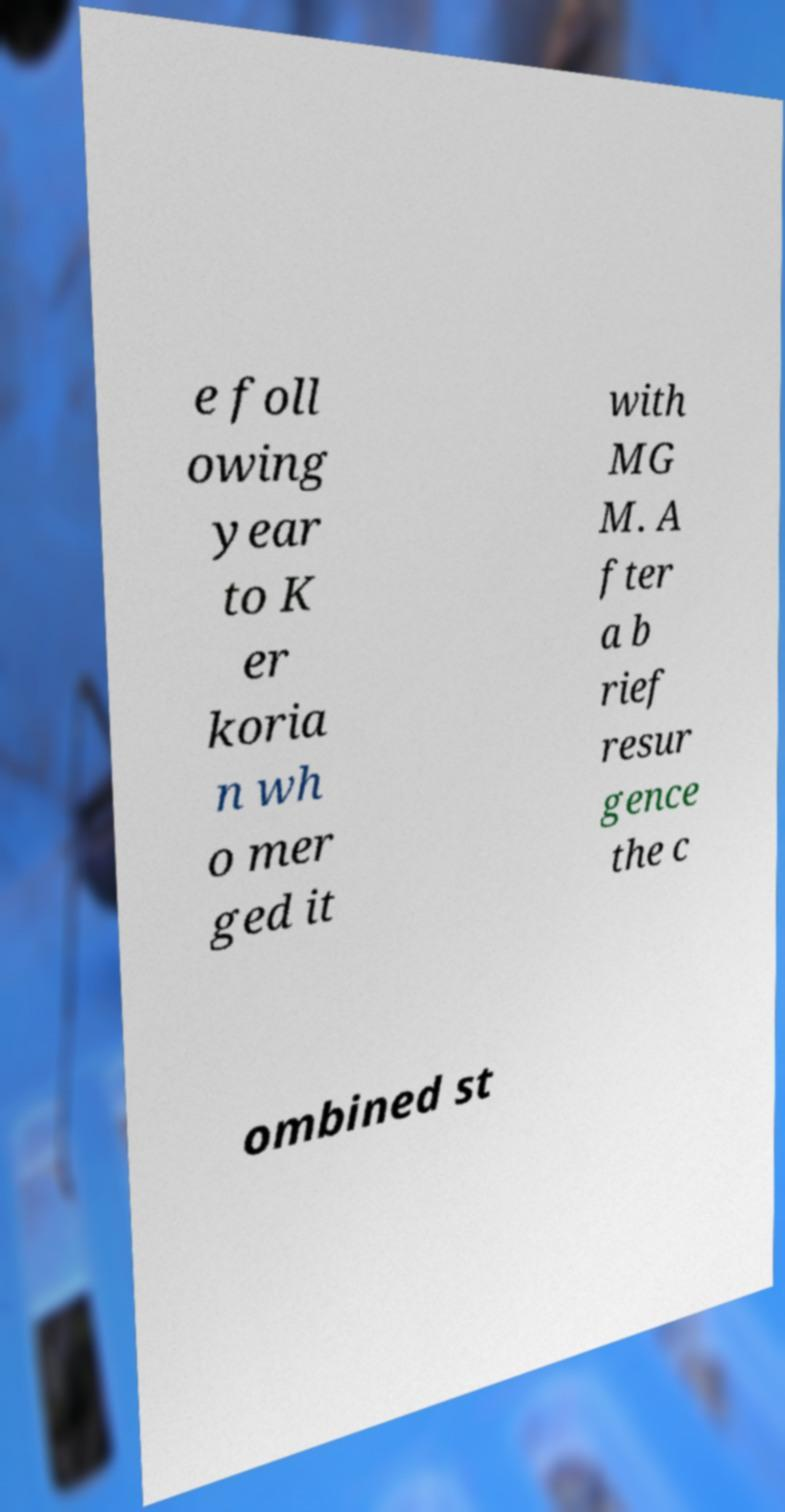Can you read and provide the text displayed in the image?This photo seems to have some interesting text. Can you extract and type it out for me? e foll owing year to K er koria n wh o mer ged it with MG M. A fter a b rief resur gence the c ombined st 